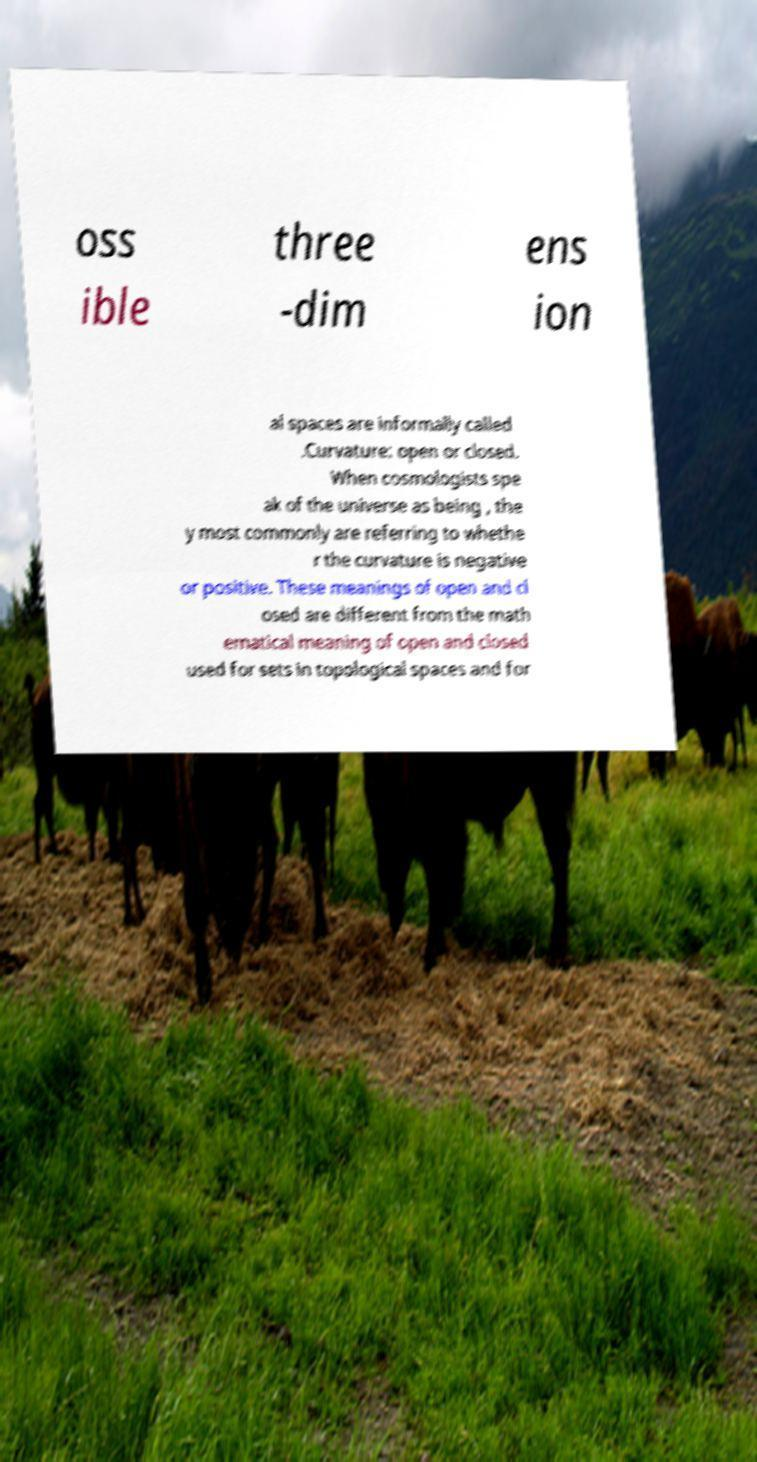I need the written content from this picture converted into text. Can you do that? oss ible three -dim ens ion al spaces are informally called .Curvature: open or closed. When cosmologists spe ak of the universe as being , the y most commonly are referring to whethe r the curvature is negative or positive. These meanings of open and cl osed are different from the math ematical meaning of open and closed used for sets in topological spaces and for 